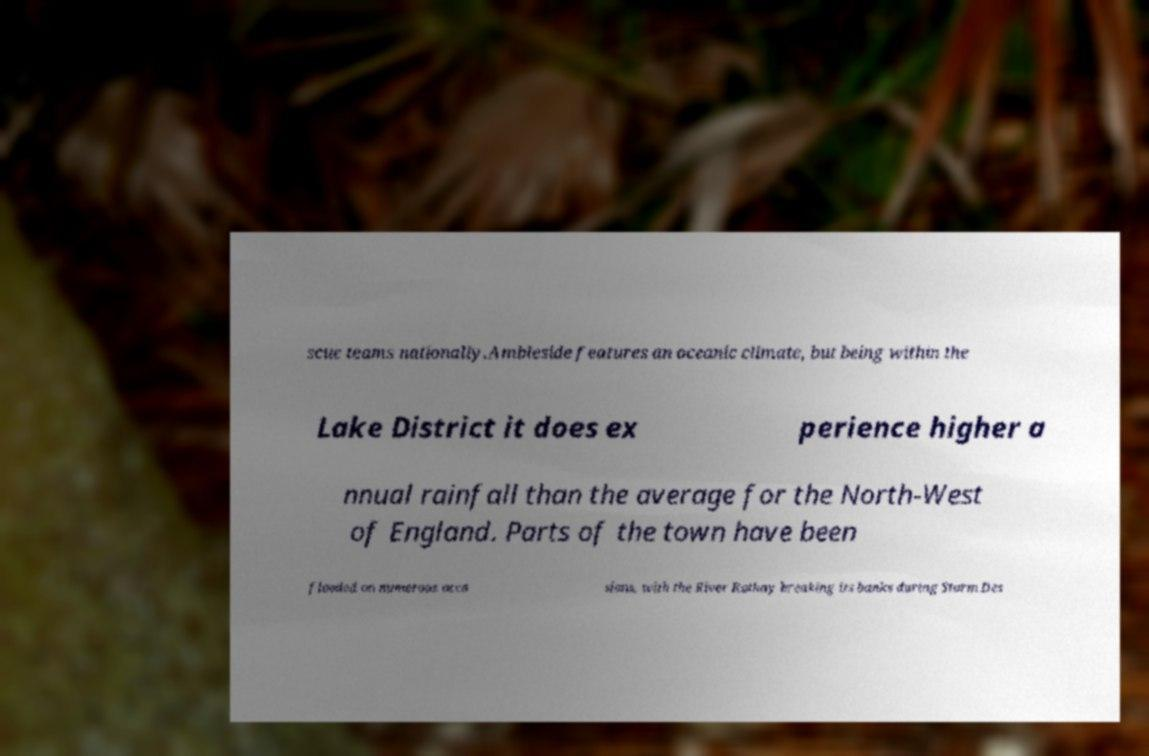There's text embedded in this image that I need extracted. Can you transcribe it verbatim? scue teams nationally.Ambleside features an oceanic climate, but being within the Lake District it does ex perience higher a nnual rainfall than the average for the North-West of England. Parts of the town have been flooded on numerous occa sions, with the River Rothay breaking its banks during Storm Des 